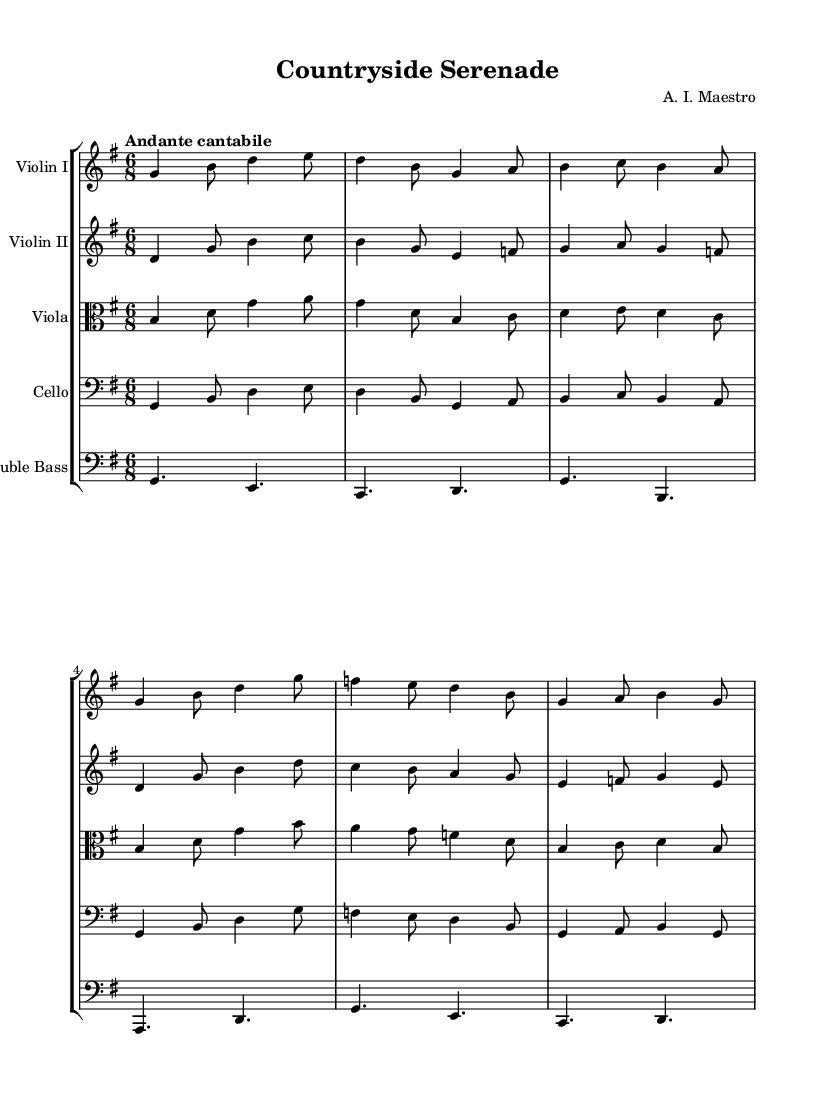What is the key signature of this music? The key signature is G major, which has one sharp (F#). This can be confirmed by looking at the key signature marking at the beginning of the staff.
Answer: G major What is the time signature of this music? The time signature is 6/8, indicated at the start of the score. This shows that there are six eighth notes in each measure.
Answer: 6/8 What is the tempo marking for this piece? The tempo marking is "Andante cantabile", which indicates a moderately slow pace with a singing style, found at the beginning of the music.
Answer: Andante cantabile Which instruments are included in this symphony? The instruments present in this music are Violin I, Violin II, Viola, Cello, and Double Bass. Each instrument has its own staff with the respective name indicated.
Answer: Violin I, Violin II, Viola, Cello, Double Bass How many measures are there in the first violin part? There are eight measures in the first violin part, determined by counting the groupings separated by vertical lines on the staff.
Answer: 8 What is the role of the bass in this symphony? The bass typically provides harmonic foundation and rhythmic support. In this score, it offers a lower melodic line and underpins the harmony played by the strings above it.
Answer: Harmonic foundation What does the use of 6/8 time signature suggest about the style of the symphony? The use of a 6/8 time signature suggests a dance-like or lilting feel, which is characteristic of Romantic-era symphonies aimed at evoking pastoral imagery and a sense of movement reminiscent of the countryside.
Answer: Dance-like feel 